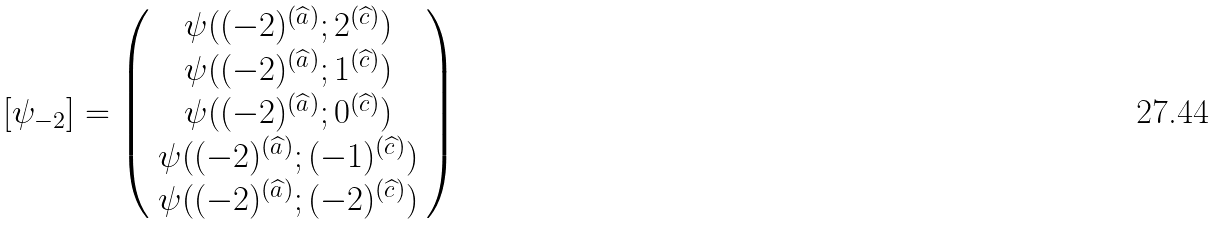Convert formula to latex. <formula><loc_0><loc_0><loc_500><loc_500>[ \psi _ { - 2 } ] = \left ( \begin{array} { c } \psi ( ( - 2 ) ^ { ( \widehat { a } ) } ; 2 ^ { ( \widehat { c } ) } ) \\ \psi ( ( - 2 ) ^ { ( \widehat { a } ) } ; 1 ^ { ( \widehat { c } ) } ) \\ \psi ( ( - 2 ) ^ { ( \widehat { a } ) } ; 0 ^ { ( \widehat { c } ) } ) \\ \psi ( ( - 2 ) ^ { ( \widehat { a } ) } ; ( - 1 ) ^ { ( \widehat { c } ) } ) \\ \psi ( ( - 2 ) ^ { ( \widehat { a } ) } ; ( - 2 ) ^ { ( \widehat { c } ) } ) \end{array} \right )</formula> 